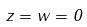Convert formula to latex. <formula><loc_0><loc_0><loc_500><loc_500>z = w = 0</formula> 